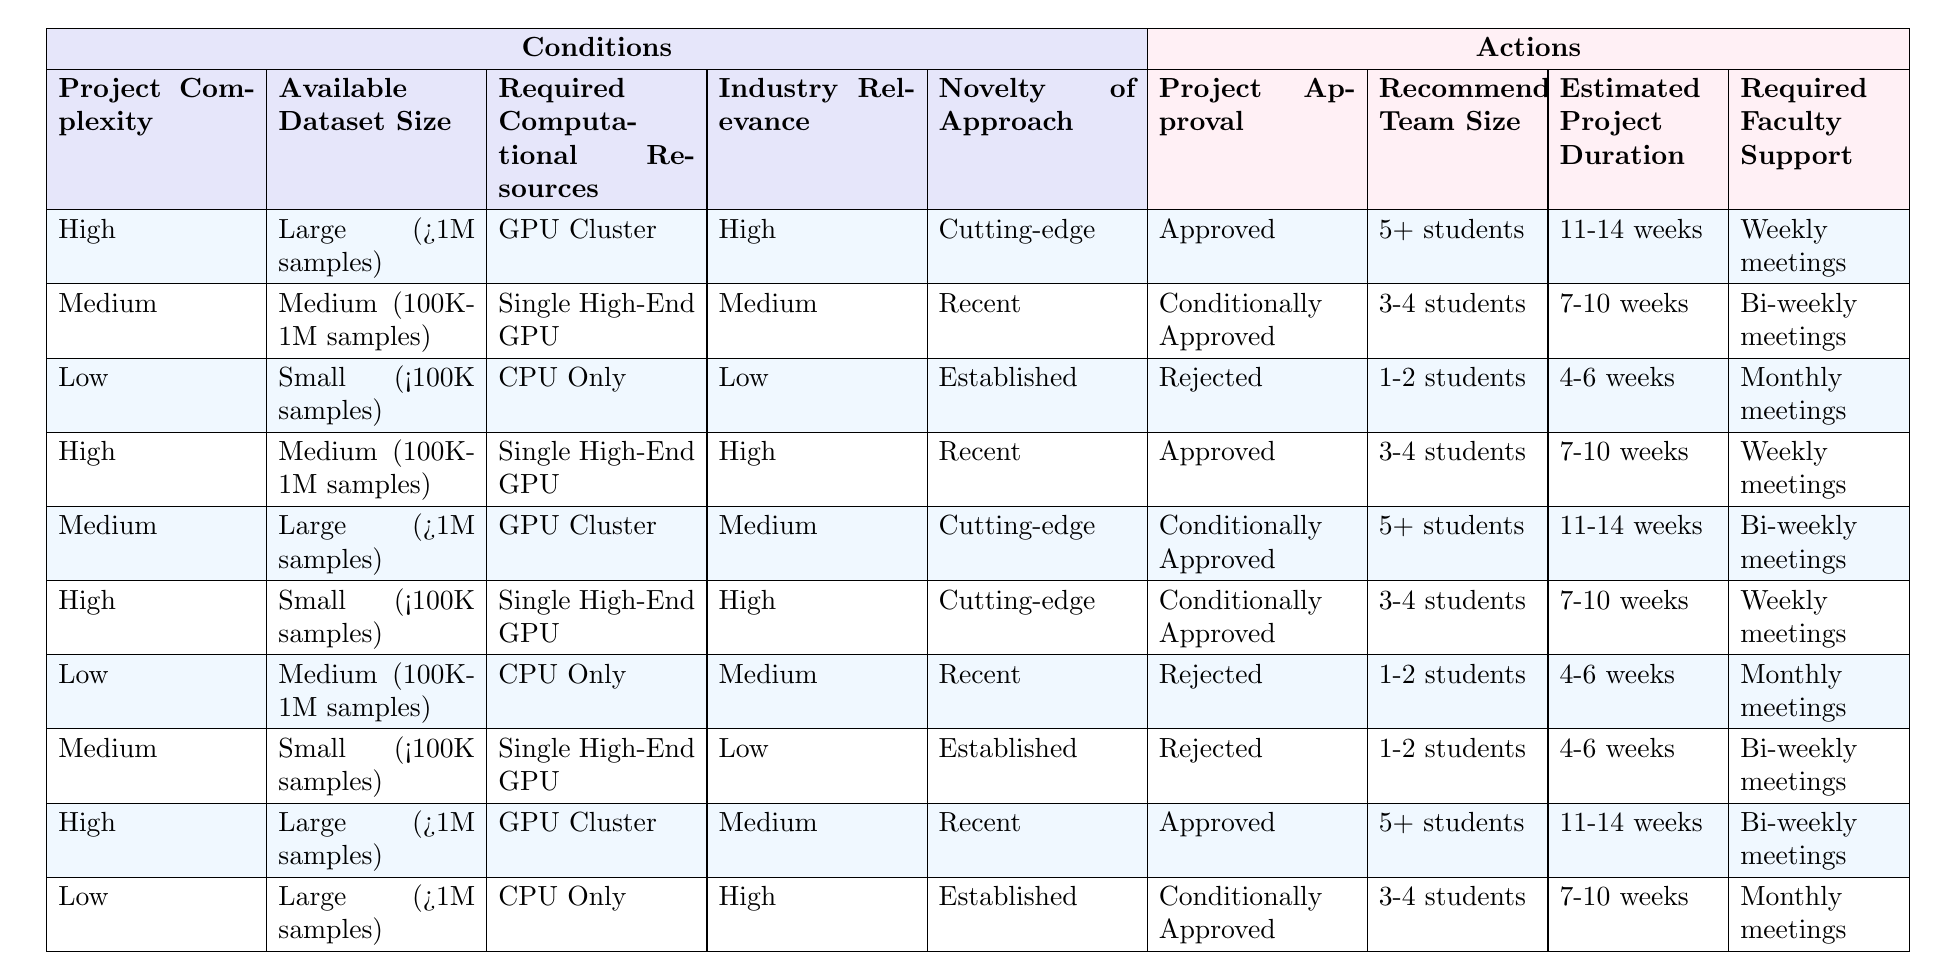What is the project approval status for a project with high complexity, a large dataset, high industry relevance, and a cutting-edge approach? In the table, we look for a row where the project complexity is high, the available dataset size is large, the industry relevance is high, and the novelty of approach is cutting-edge. This matches the first row. The project approval status in this case is "Approved."
Answer: Approved How many students are recommended for a project that is conditionally approved and has a medium dataset size? We find the row with the action "Conditionally Approved." There are two rows that meet this condition: the second and the fifth rows correspond to this. Both recommend "3-4 students."
Answer: 3-4 students Is there a project that requires a single high-end GPU and is approved? We can check each row of the table for projects that require a single high-end GPU and check their approval status. The second and fourth rows specify this condition, and both are either conditionally approved or approved. Thus, yes, there are projects that meet the criteria.
Answer: Yes What is the required faculty support for a project with low complexity, small dataset size, and established novelty of approach? We look for the conditions: low complexity, small dataset size, and established novelty of approach, which matches the sixth row in the table. This row states that the required faculty support is "Monthly meetings."
Answer: Monthly meetings If a project requires a GPU cluster and receives an approval status, what is the estimated project duration for such projects? We first identify all rows with "GPU Cluster" that also have an approval status. The first, fourth, and ninth rows have a GPU cluster and are approved. The estimated project durations from these rows are 11-14 weeks, 7-10 weeks, and 11-14 weeks, respectively. To find the mode, "11-14 weeks" appears twice, making it the answer.
Answer: 11-14 weeks What are the different project approval statuses for projects with medium industry relevance? We examine all rows with "Medium" under industry relevance. The second, fifth, and seventh rows are the only ones matching this condition, and their project approval statuses are "Conditionally Approved" and "Approved."
Answer: Conditionally Approved, Approved Are there projects with a required computational resource of "CPU Only" that are approved? We need to find rows where "Required Computational Resources" is "CPU Only" and check their project approval statuses. The third and seventh rows meet this condition. Both rows indicate they are "Rejected," meaning there are no approved projects under these criteria.
Answer: No What is the average recommended team size for projects that are conditionally approved? We find the rows that are marked as "Conditionally Approved," which are the second, fifth, sixth, and ninth rows. The recommended team sizes in these rows are "3-4 students" (2), "5+ students" (1), and "3-4 students" (1), giving us an average of 3.5 students. Thus, the average recommended team size is 4 students.
Answer: 4 students 